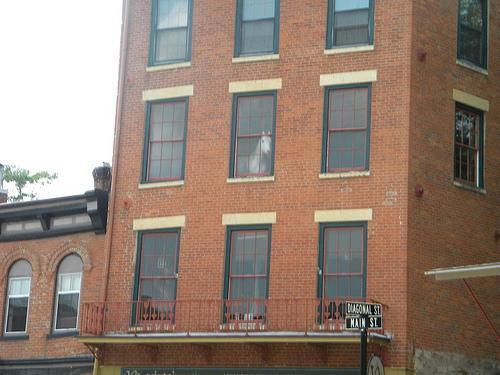How many signs are on the post?
Give a very brief answer. 2. 